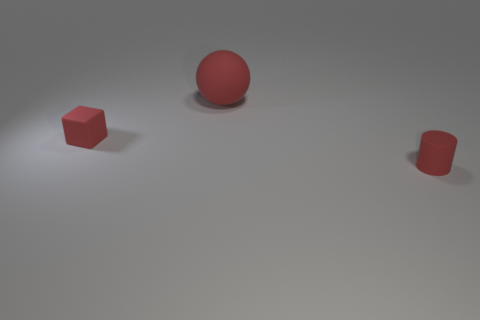Add 1 big yellow shiny blocks. How many objects exist? 4 Subtract all spheres. How many objects are left? 2 Subtract 0 green spheres. How many objects are left? 3 Subtract all tiny matte blocks. Subtract all big red spheres. How many objects are left? 1 Add 1 red cylinders. How many red cylinders are left? 2 Add 3 large brown shiny things. How many large brown shiny things exist? 3 